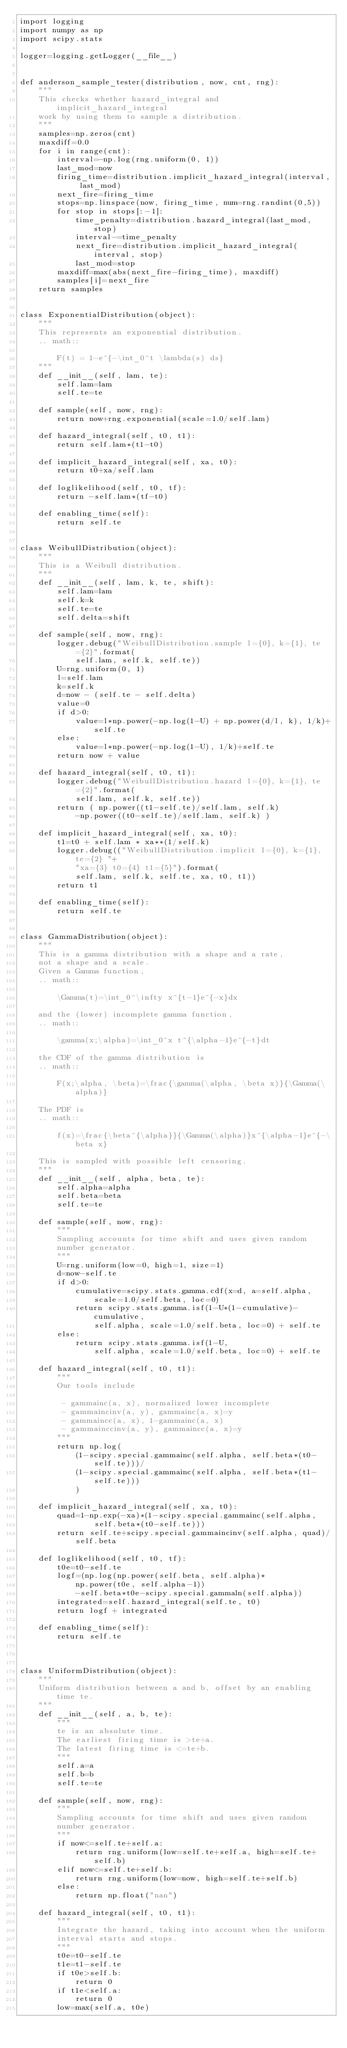Convert code to text. <code><loc_0><loc_0><loc_500><loc_500><_Python_>import logging
import numpy as np
import scipy.stats

logger=logging.getLogger(__file__)


def anderson_sample_tester(distribution, now, cnt, rng):
    """
    This checks whether hazard_integral and implicit_hazard_integral
    work by using them to sample a distribution.
    """
    samples=np.zeros(cnt)
    maxdiff=0.0
    for i in range(cnt):
        interval=-np.log(rng.uniform(0, 1))
        last_mod=now
        firing_time=distribution.implicit_hazard_integral(interval, last_mod)
        next_fire=firing_time
        stops=np.linspace(now, firing_time, num=rng.randint(0,5))
        for stop in stops[:-1]:
            time_penalty=distribution.hazard_integral(last_mod, stop)
            interval-=time_penalty
            next_fire=distribution.implicit_hazard_integral(interval, stop)
            last_mod=stop
        maxdiff=max(abs(next_fire-firing_time), maxdiff)
        samples[i]=next_fire
    return samples


class ExponentialDistribution(object):
    """
    This represents an exponential distribution.
    .. math::

        F(t) = 1-e^{-\int_0^t \lambda(s) ds}
    """
    def __init__(self, lam, te):
        self.lam=lam
        self.te=te

    def sample(self, now, rng):
        return now+rng.exponential(scale=1.0/self.lam)

    def hazard_integral(self, t0, t1):
        return self.lam*(t1-t0)

    def implicit_hazard_integral(self, xa, t0):
        return t0+xa/self.lam

    def loglikelihood(self, t0, tf):
        return -self.lam*(tf-t0)

    def enabling_time(self):
        return self.te


class WeibullDistribution(object):
    """
    This is a Weibull distribution.
    """
    def __init__(self, lam, k, te, shift):
        self.lam=lam
        self.k=k
        self.te=te
        self.delta=shift

    def sample(self, now, rng):
        logger.debug("WeibullDistribution.sample l={0}, k={1}, te={2}".format(
            self.lam, self.k, self.te))
        U=rng.uniform(0, 1)
        l=self.lam
        k=self.k
        d=now - (self.te - self.delta)
        value=0
        if d>0:
            value=l*np.power(-np.log(1-U) + np.power(d/l, k), 1/k)+self.te
        else:
            value=l*np.power(-np.log(1-U), 1/k)+self.te
        return now + value

    def hazard_integral(self, t0, t1):
        logger.debug("WeibullDistribution.hazard l={0}, k={1}, te={2}".format(
            self.lam, self.k, self.te))
        return ( np.power((t1-self.te)/self.lam, self.k)
            -np.power((t0-self.te)/self.lam, self.k) )

    def implicit_hazard_integral(self, xa, t0):
        t1=t0 + self.lam * xa**(1/self.k)
        logger.debug(("WeibullDistribution.implicit l={0}, k={1}, te={2} "+
            "xa={3} t0={4} t1={5}").format(
            self.lam, self.k, self.te, xa, t0, t1))
        return t1

    def enabling_time(self):
        return self.te


class GammaDistribution(object):
    """
    This is a gamma distribution with a shape and a rate,
    not a shape and a scale.
    Given a Gamma function,
    .. math::

        \Gamma(t)=\int_0^\infty x^{t-1}e^{-x}dx

    and the (lower) incomplete gamma function,
    .. math::

        \gamma(x;\alpha)=\int_0^x t^{\alpha-1}e^{-t}dt

    the CDF of the gamma distribution is
    .. math::

        F(x;\alpha, \beta)=\frac{\gamma(\alpha, \beta x)}{\Gamma(\alpha)}

    The PDF is
    .. math::

        f(x)=\frac{\beta^{\alpha}}{\Gamma(\alpha)}x^{\alpha-1}e^{-\beta x}

    This is sampled with possible left censoring. 
    """
    def __init__(self, alpha, beta, te):
        self.alpha=alpha
        self.beta=beta
        self.te=te

    def sample(self, now, rng):
        """
        Sampling accounts for time shift and uses given random
        number generator.
        """
        U=rng.uniform(low=0, high=1, size=1)
        d=now-self.te
        if d>0:
            cumulative=scipy.stats.gamma.cdf(x=d, a=self.alpha,
                scale=1.0/self.beta, loc=0)
            return scipy.stats.gamma.isf(1-U*(1-cumulative)-cumulative,
                self.alpha, scale=1.0/self.beta, loc=0) + self.te
        else:
            return scipy.stats.gamma.isf(1-U,
                self.alpha, scale=1.0/self.beta, loc=0) + self.te

    def hazard_integral(self, t0, t1):
        """
        Our tools include

         - gammainc(a, x), normalized lower incomplete
         - gammaincinv(a, y), gammainc(a, x)=y
         - gammaincc(a, x), 1-gammainc(a, x)
         - gammainccinv(a, y), gammaincc(a, x)=y
        """
        return np.log(
            (1-scipy.special.gammainc(self.alpha, self.beta*(t0-self.te)))/
            (1-scipy.special.gammainc(self.alpha, self.beta*(t1-self.te)))
            )

    def implicit_hazard_integral(self, xa, t0):
        quad=1-np.exp(-xa)*(1-scipy.special.gammainc(self.alpha,
                self.beta*(t0-self.te)))
        return self.te+scipy.special.gammaincinv(self.alpha, quad)/self.beta

    def loglikelihood(self, t0, tf):
        t0e=t0-self.te
        logf=(np.log(np.power(self.beta, self.alpha)*
            np.power(t0e, self.alpha-1))
            -self.beta*t0e-scipy.special.gammaln(self.alpha))
        integrated=self.hazard_integral(self.te, t0)
        return logf + integrated

    def enabling_time(self):
        return self.te



class UniformDistribution(object):
    """
    Uniform distribution between a and b, offset by an enabling time te.
    """
    def __init__(self, a, b, te):
        """
        te is an absolute time.
        The earliest firing time is >te+a.
        The latest firing time is <=te+b.
        """
        self.a=a
        self.b=b
        self.te=te

    def sample(self, now, rng):
        """
        Sampling accounts for time shift and uses given random
        number generator.
        """
        if now<=self.te+self.a:
            return rng.uniform(low=self.te+self.a, high=self.te+self.b)
        elif now<=self.te+self.b:
            return rng.uniform(low=now, high=self.te+self.b)
        else:
            return np.float("nan")

    def hazard_integral(self, t0, t1):
        """
        Integrate the hazard, taking into account when the uniform
        interval starts and stops.
        """
        t0e=t0-self.te
        t1e=t1-self.te
        if t0e>self.b:
            return 0
        if t1e<self.a:
            return 0
        low=max(self.a, t0e)</code> 